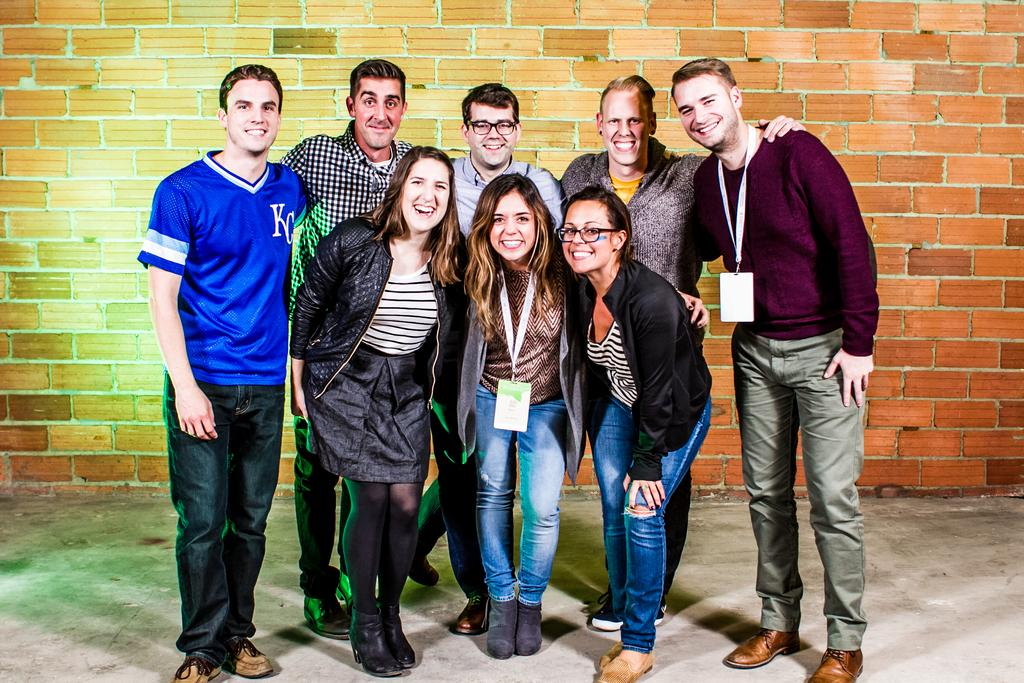What can be seen in the image? There are people standing in the image. Where are the people standing? The people are standing on the floor. What else is visible in the image besides the people? There is a wall visible in the image. What type of van can be seen parked next to the wall in the image? There is no van present in the image; only people standing on the floor and a wall are visible. 